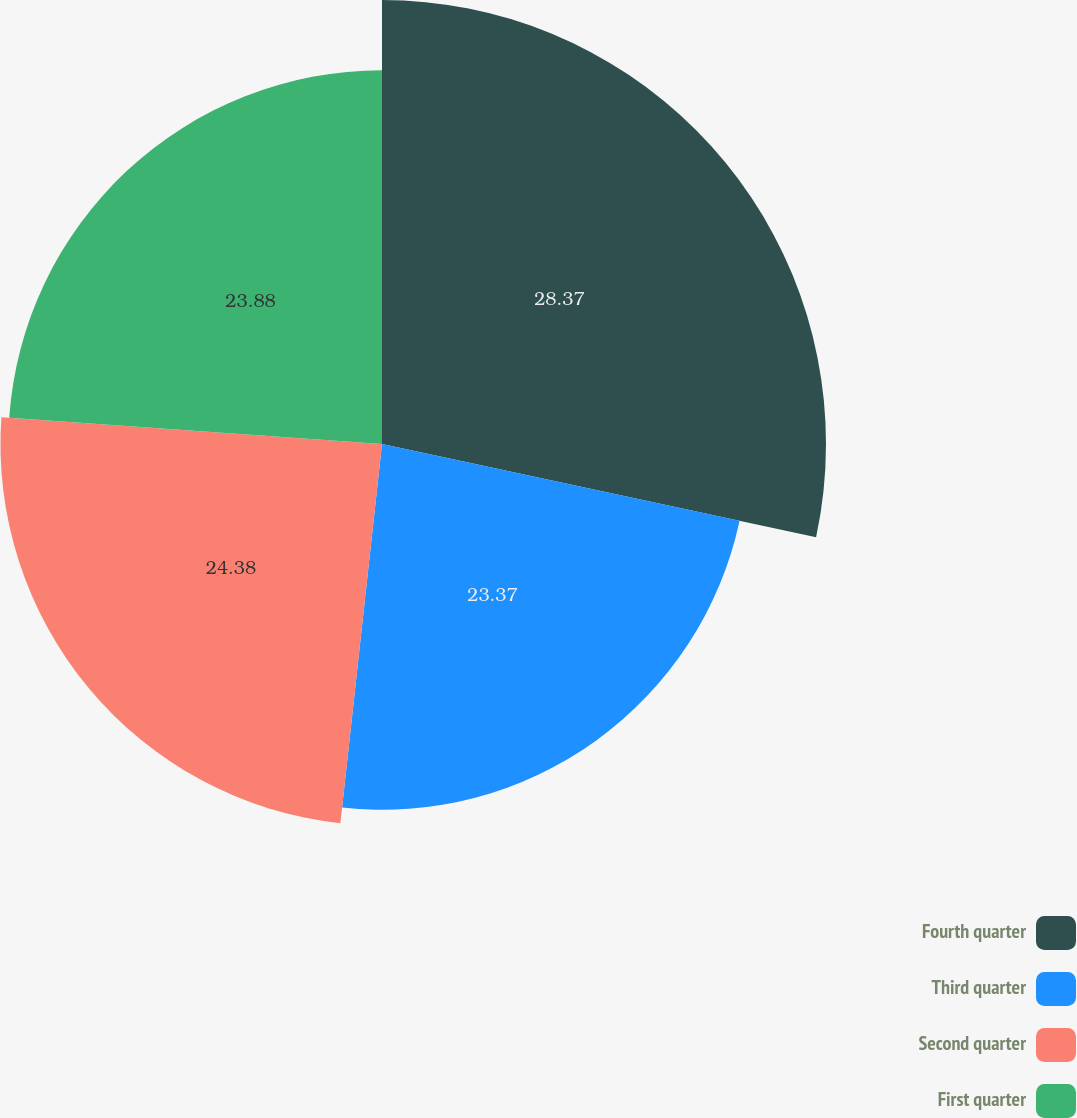Convert chart to OTSL. <chart><loc_0><loc_0><loc_500><loc_500><pie_chart><fcel>Fourth quarter<fcel>Third quarter<fcel>Second quarter<fcel>First quarter<nl><fcel>28.37%<fcel>23.37%<fcel>24.38%<fcel>23.88%<nl></chart> 